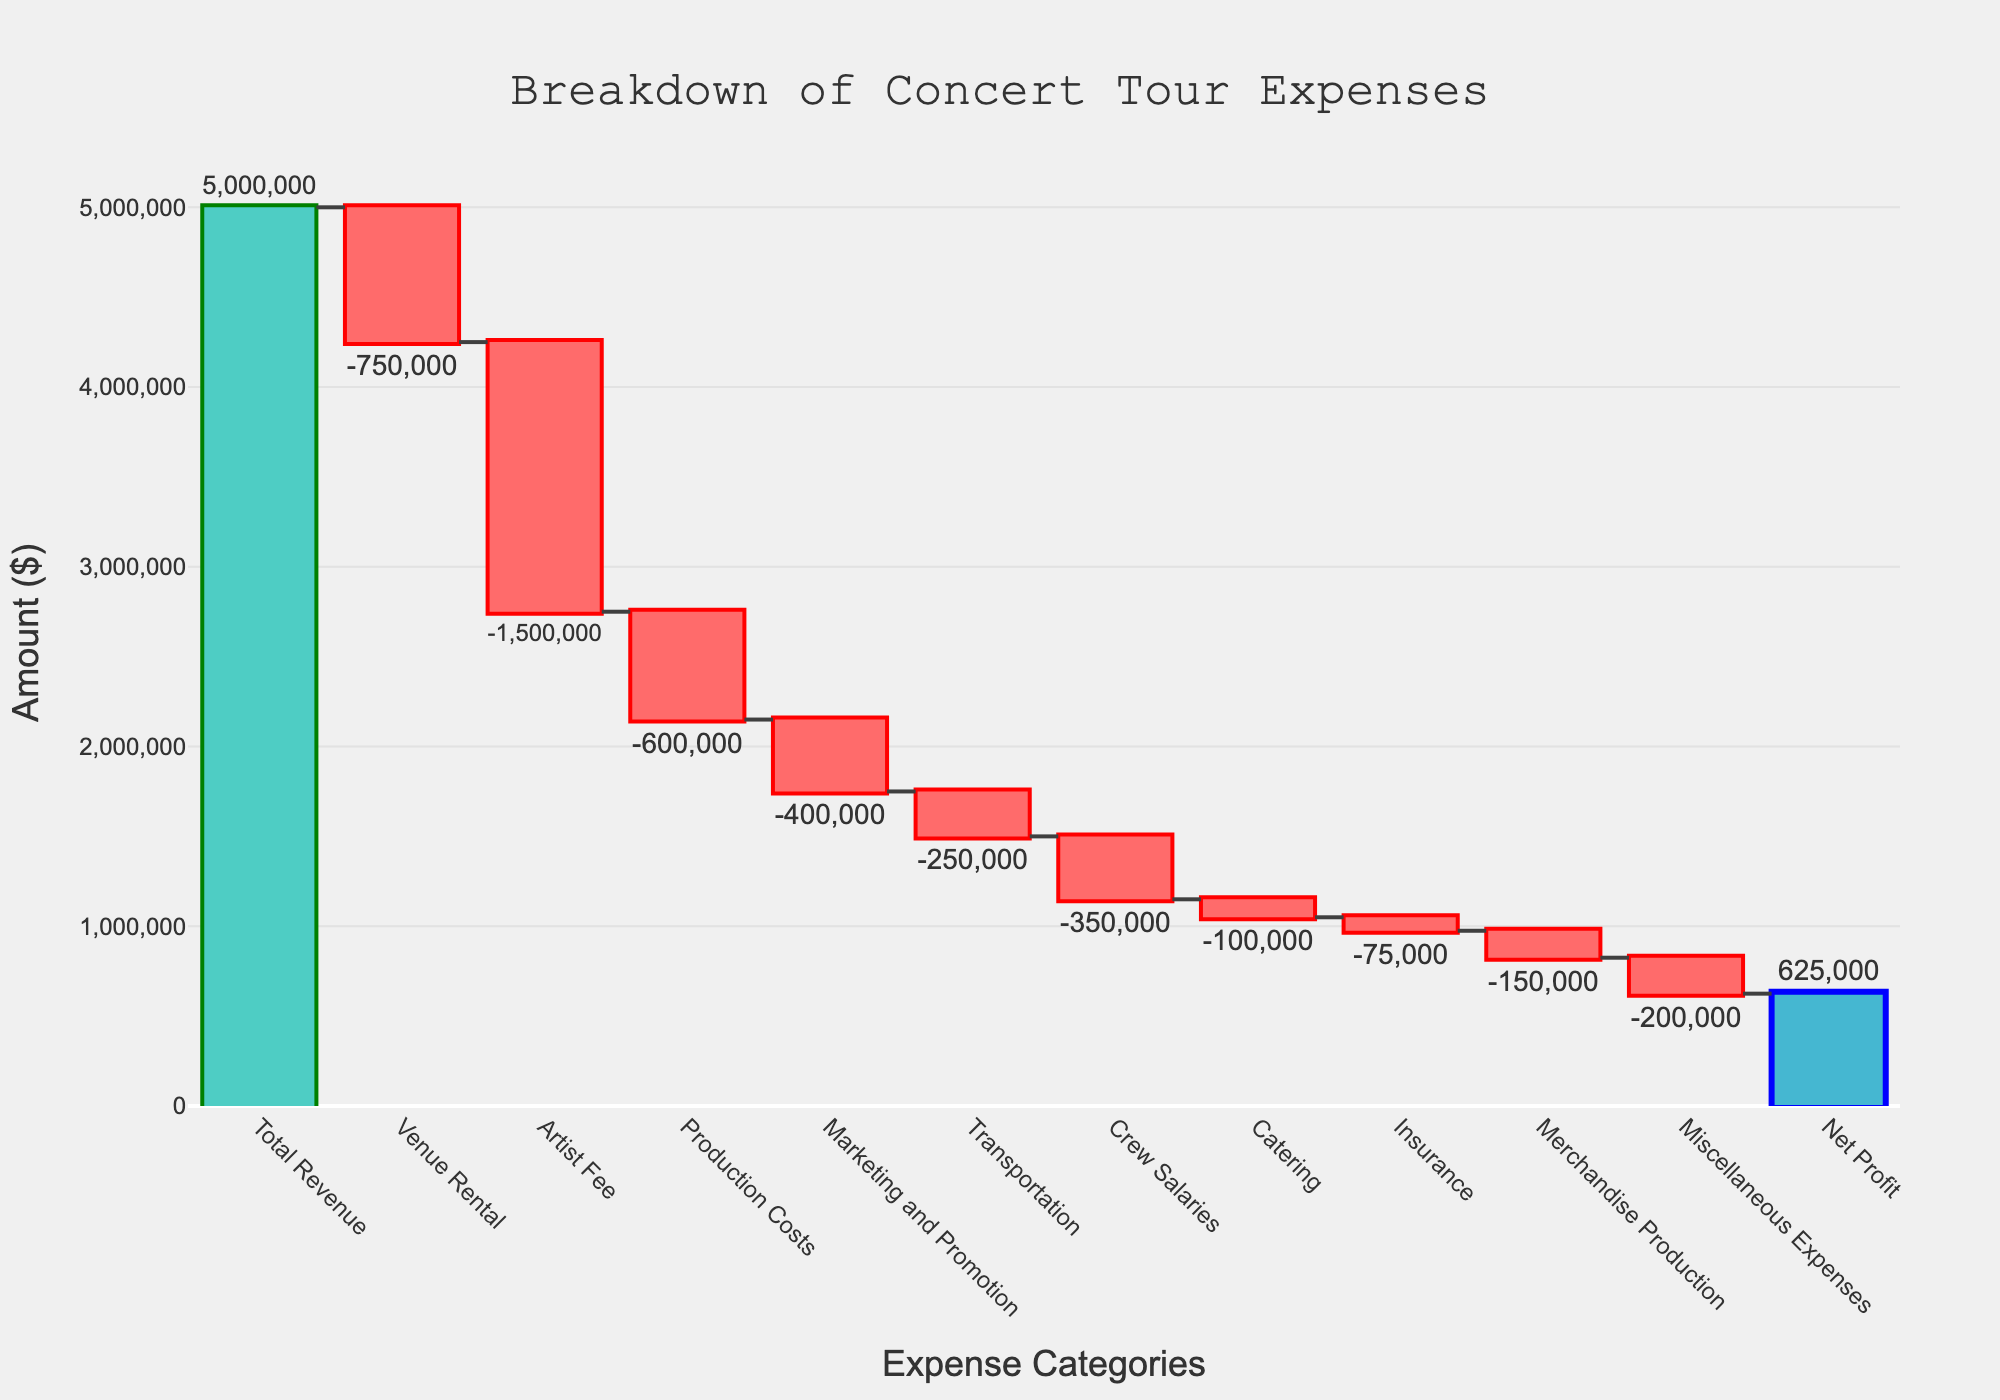What is the total revenue for the concert tour? The total revenue is represented by the first bar in the waterfall chart labeled "Total Revenue." The value for this bar is shown as $5,000,000.
Answer: $5,000,000 What category has the highest expense? We need to identify the category with the longest negative bar in the downward direction. The "Artist Fee" shows the largest negative value at $1,500,000.
Answer: Artist Fee What is the net profit from the concert tour? The net profit is represented by the last bar labeled "Net Profit." The value for this bar is shown as $625,000.
Answer: $625,000 How much is spent on venue rental? The expense for the venue rental is depicted by the bar labeled "Venue Rental." The value is $750,000.
Answer: $750,000 Which expense category is higher: Production Costs or Marketing and Promotion? We need to compare the values of the "Production Costs" and "Marketing and Promotion" bars. The "Production Costs" bar shows $600,000, while the "Marketing and Promotion" bar shows $400,000. Therefore, Production Costs is higher.
Answer: Production Costs What are the cumulative expenses by the time crew salaries are included? The expenses cumulate from "Venue Rental" to "Crew Salaries." Adding these up: $750,000 (Venue Rental) + $1,500,000 (Artist Fee) + $600,000 (Production Costs) + $400,000 (Marketing and Promotion) + $250,000 (Transportation) + $350,000 (Crew Salaries) = $3,850,000.
Answer: $3,850,000 What is the total expense for non-crew-related categories? Sum the expenses excluding "Crew Salaries": $750,000 (Venue Rental) + $1,500,000 (Artist Fee) + $600,000 (Production Costs) + $400,000 (Marketing and Promotion) + $250,000 (Transportation) + $100,000 (Catering) + $75,000 (Insurance) + $150,000 (Merchandise Production) + $200,000 (Miscellaneous Expenses). This results in $4,025,000.
Answer: $4,025,000 Which category has the lowest expense? Identify the smallest bar representing an expense. The "Insurance" bar shows the smallest expense value of $75,000.
Answer: Insurance If you remove the venue rental expense, what would the net profit be? Starting with the net profit of $625,000, add back the venue rental expense of $750,000, since removing this expense increases profit. Thus, the new net profit would be $625,000 + $750,000 = $1,375,000.
Answer: $1,375,000 